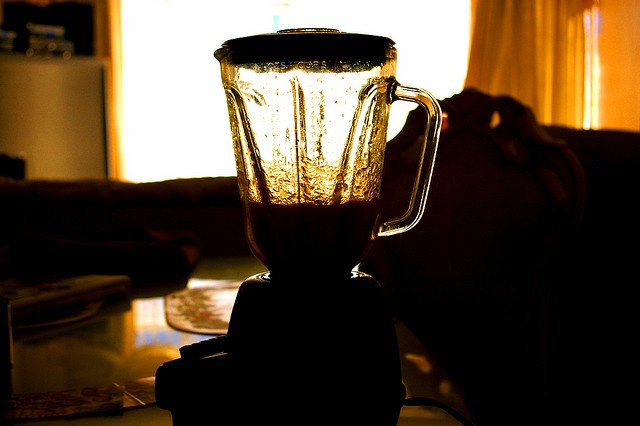Describe the objects in this image and their specific colors. I can see chair in maroon, black, and brown tones and dining table in maroon, black, brown, and beige tones in this image. 